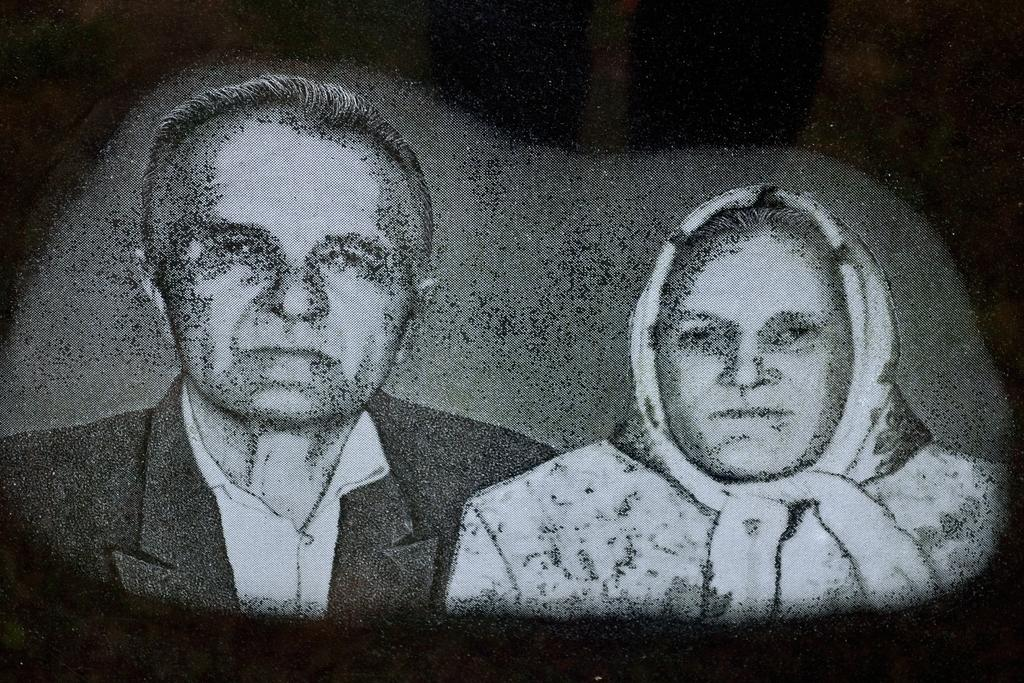What is depicted in the image? There is a picture of a man and a woman in the image. What is the man wearing in the image? The man is wearing a black blazer. What is the facial expression of the man and the woman in the image? Both the man and the woman are smiling. What type of bread can be seen in the hands of the man in the image? There is no bread present in the image; it features a picture of a man and a woman. Is the writer of the image visible in the picture? The image does not depict the writer; it is a picture of a man and a woman. 